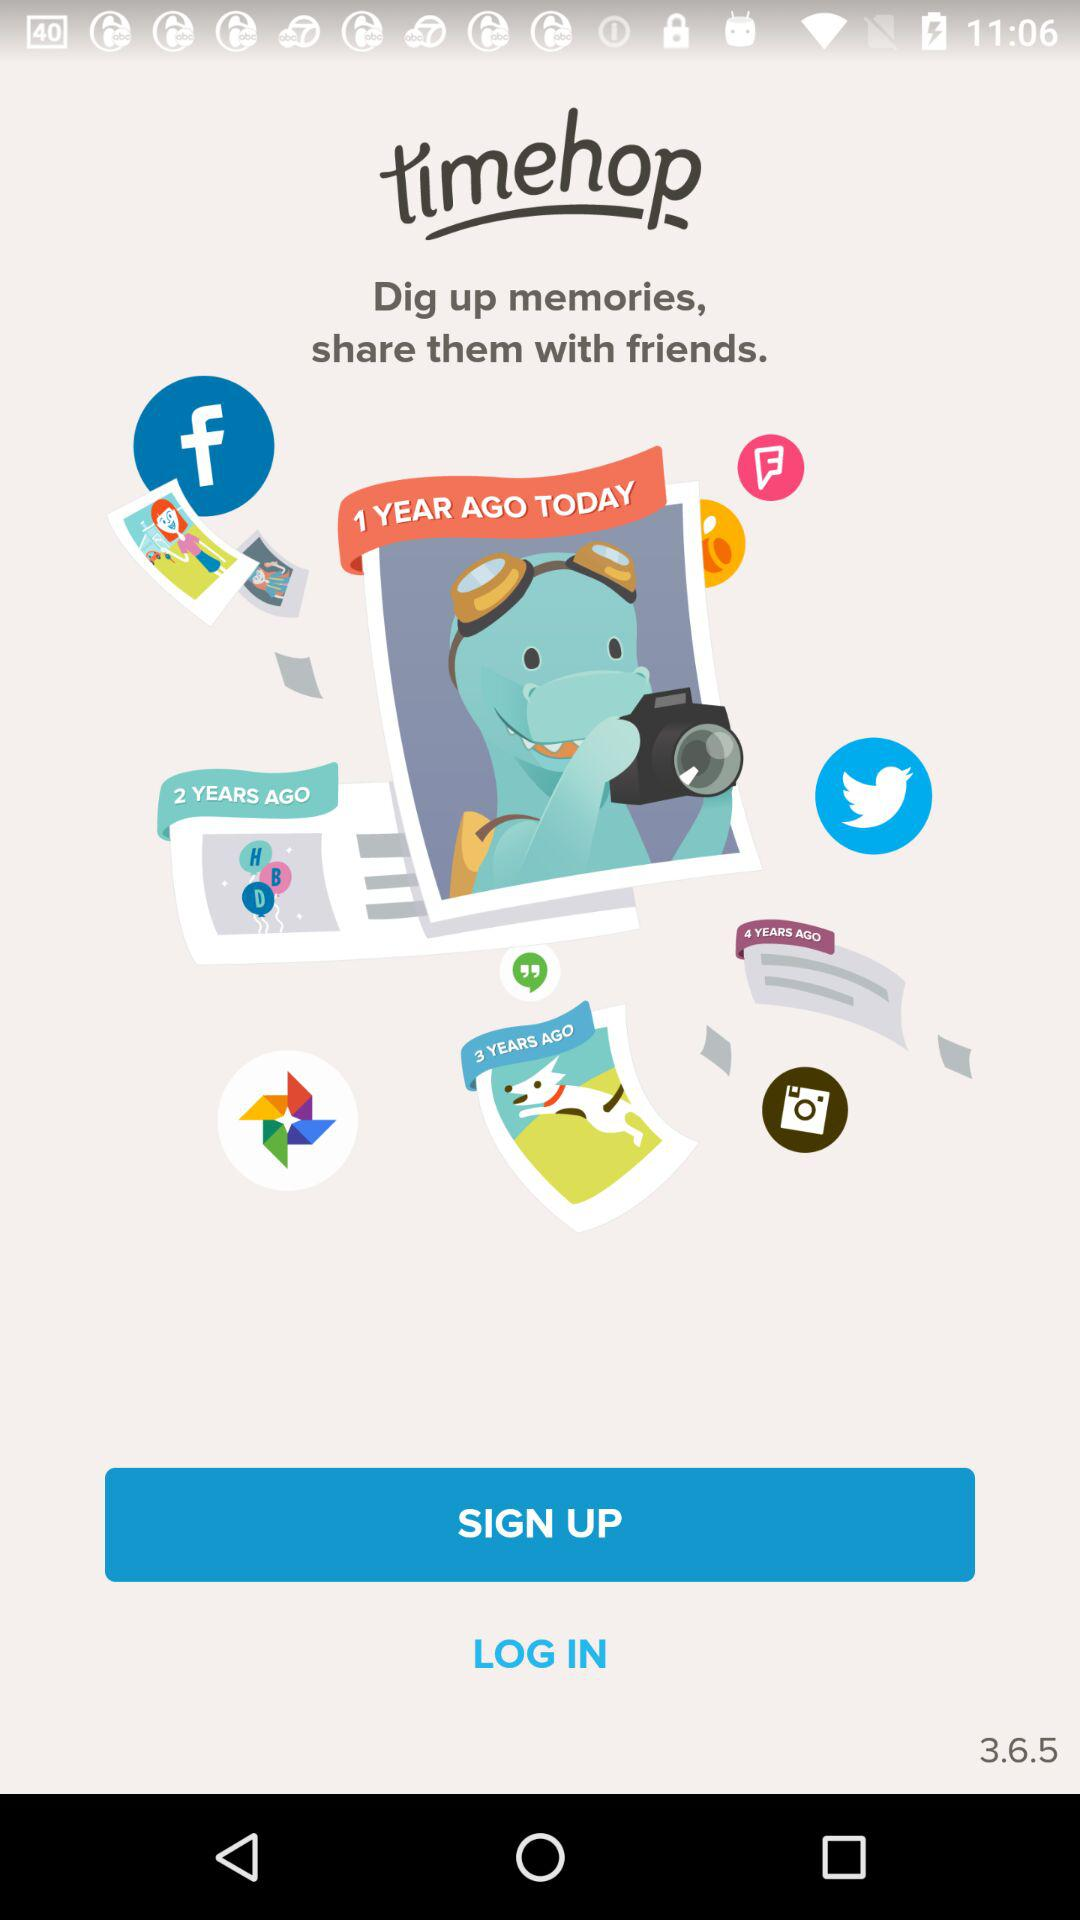What is the name of the application? The name of the application is "timehop". 